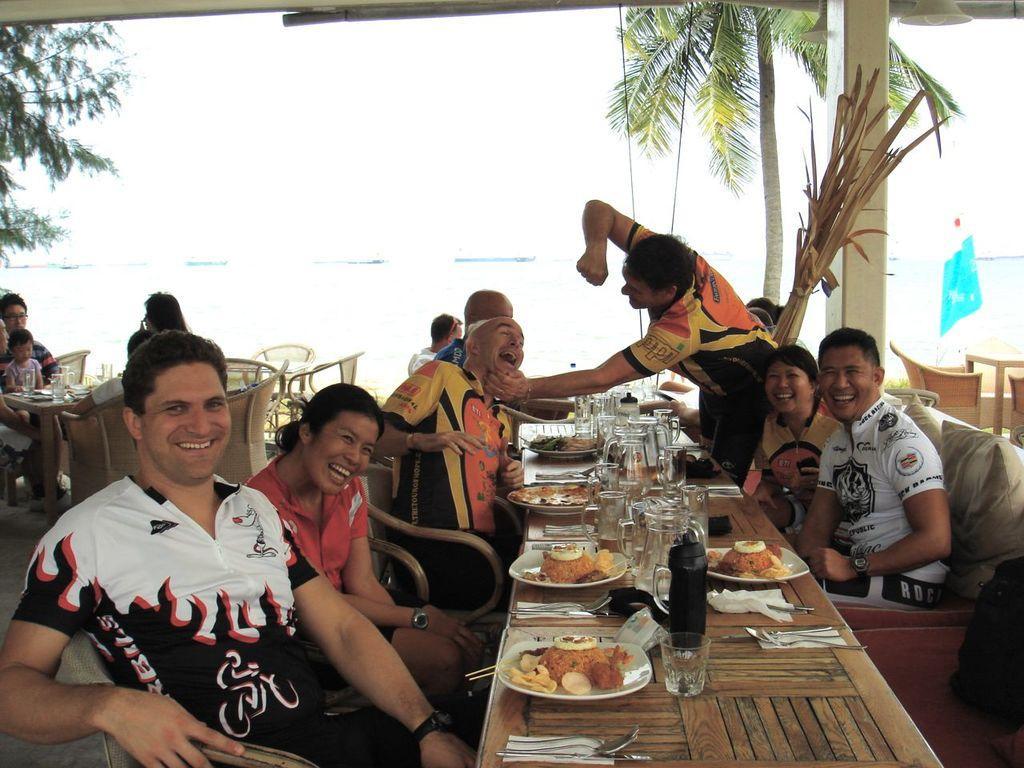Could you give a brief overview of what you see in this image? In this image there are group of persons who are sitting and having their food and at the background of the image there are trees and ocean. 